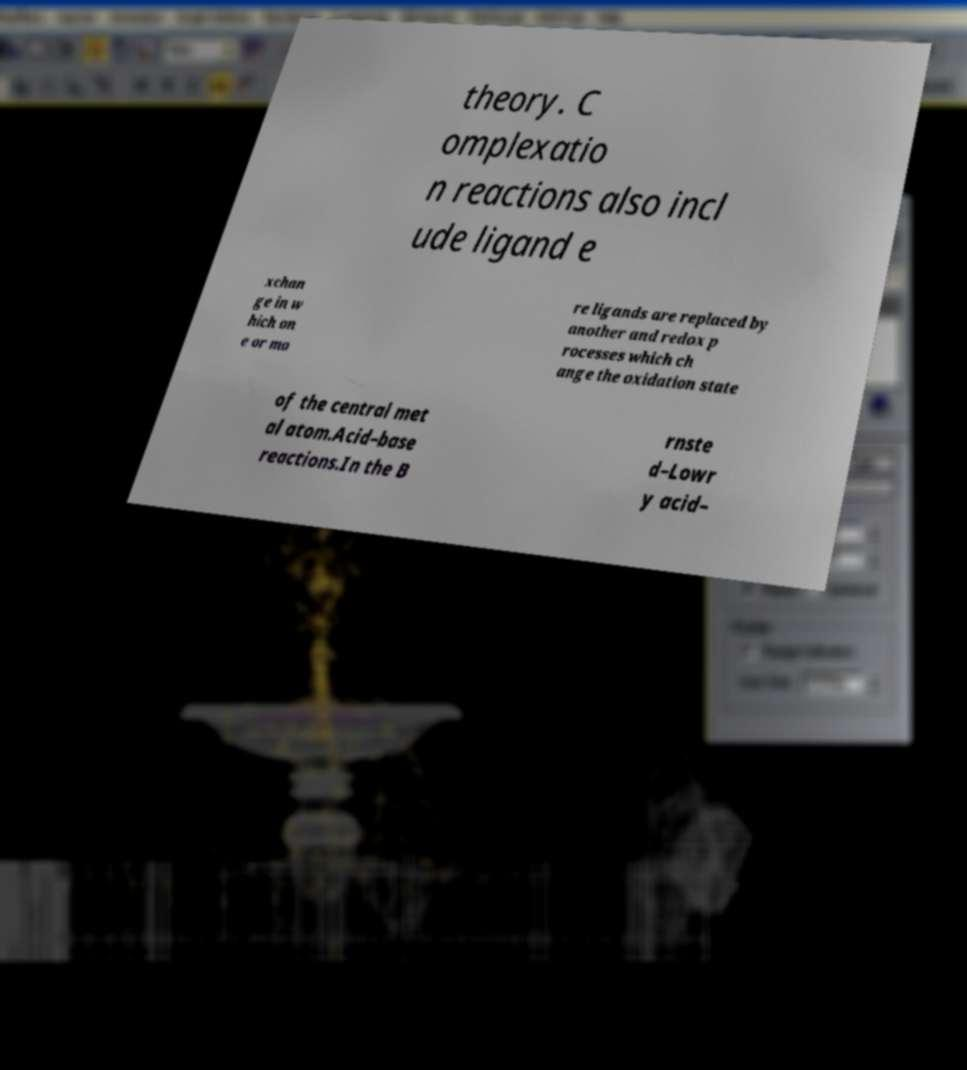For documentation purposes, I need the text within this image transcribed. Could you provide that? theory. C omplexatio n reactions also incl ude ligand e xchan ge in w hich on e or mo re ligands are replaced by another and redox p rocesses which ch ange the oxidation state of the central met al atom.Acid–base reactions.In the B rnste d–Lowr y acid– 